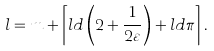Convert formula to latex. <formula><loc_0><loc_0><loc_500><loc_500>l = m + \left \lceil l d \left ( 2 + \frac { 1 } { 2 \varepsilon } \right ) + l d \pi \right \rceil .</formula> 